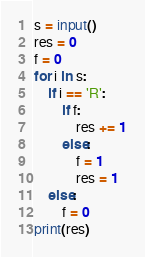<code> <loc_0><loc_0><loc_500><loc_500><_Python_>s = input()
res = 0
f = 0
for i in s:
    if i == 'R':
        if f:
            res += 1
        else:
            f = 1
            res = 1
    else:
        f = 0
print(res)</code> 